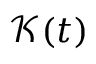Convert formula to latex. <formula><loc_0><loc_0><loc_500><loc_500>\mathcal { K } ( t )</formula> 